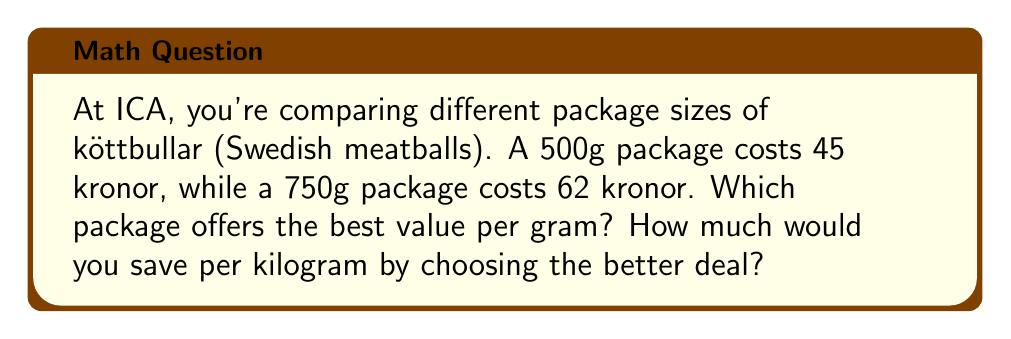Help me with this question. 1. Calculate the price per gram for the 500g package:
   $\frac{45 \text{ kronor}}{500 \text{ g}} = 0.09 \text{ kronor/g}$

2. Calculate the price per gram for the 750g package:
   $\frac{62 \text{ kronor}}{750 \text{ g}} \approx 0.0827 \text{ kronor/g}$

3. Compare the prices:
   The 750g package is cheaper per gram (0.0827 kronor/g < 0.09 kronor/g)

4. Calculate the difference in price per gram:
   $0.09 - 0.0827 = 0.0073 \text{ kronor/g}$

5. Convert the savings to kronor per kilogram:
   $0.0073 \text{ kronor/g} \times 1000 \text{ g/kg} = 7.3 \text{ kronor/kg}$
Answer: 750g package; 7.3 kronor/kg savings 